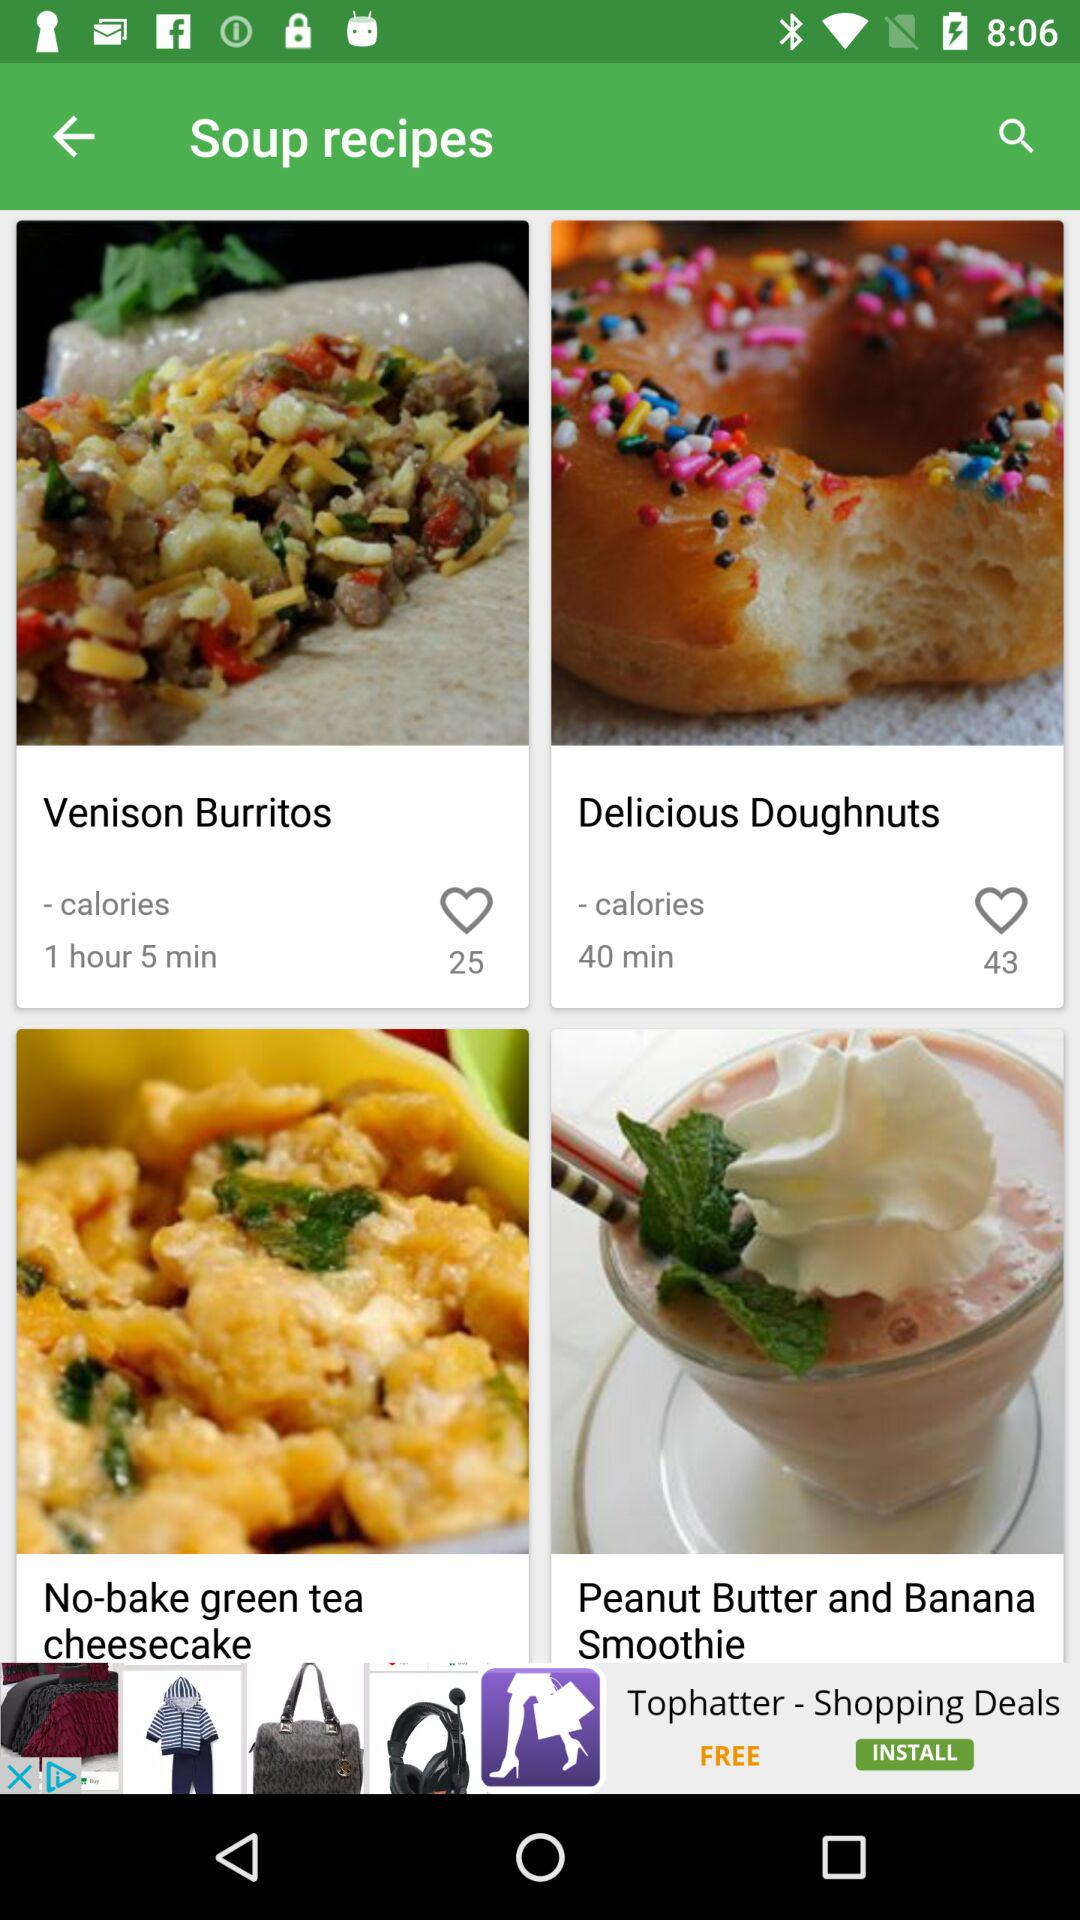How many likes are there for "Delicious Doughnuts"? There are 43 likes. 